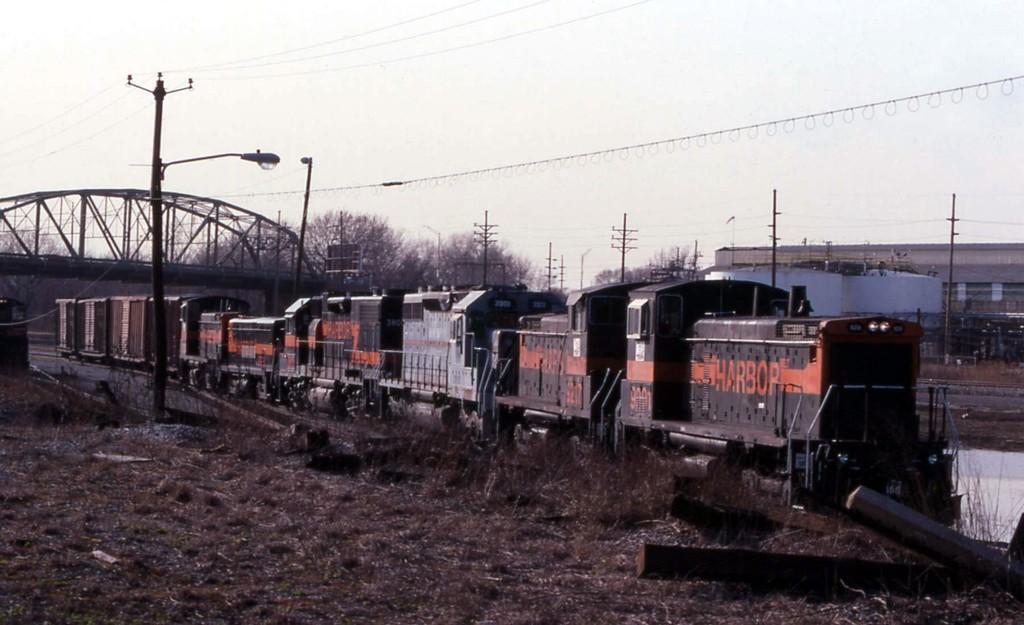In one or two sentences, can you explain what this image depicts? In this picture I can see the train on the railway track. Beside the track I can see the small stone. In the back I can see the bridge, trees, electric poles, wires and shed. At the top I can see the sky. At the bottom I can see some grass. 